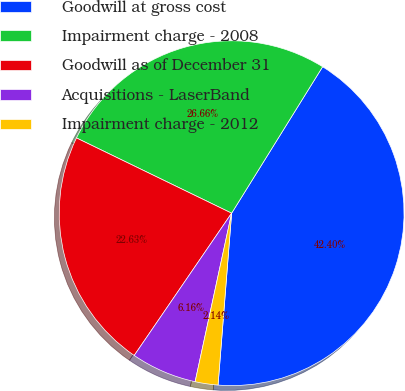Convert chart. <chart><loc_0><loc_0><loc_500><loc_500><pie_chart><fcel>Goodwill at gross cost<fcel>Impairment charge - 2008<fcel>Goodwill as of December 31<fcel>Acquisitions - LaserBand<fcel>Impairment charge - 2012<nl><fcel>42.4%<fcel>26.66%<fcel>22.63%<fcel>6.16%<fcel>2.14%<nl></chart> 